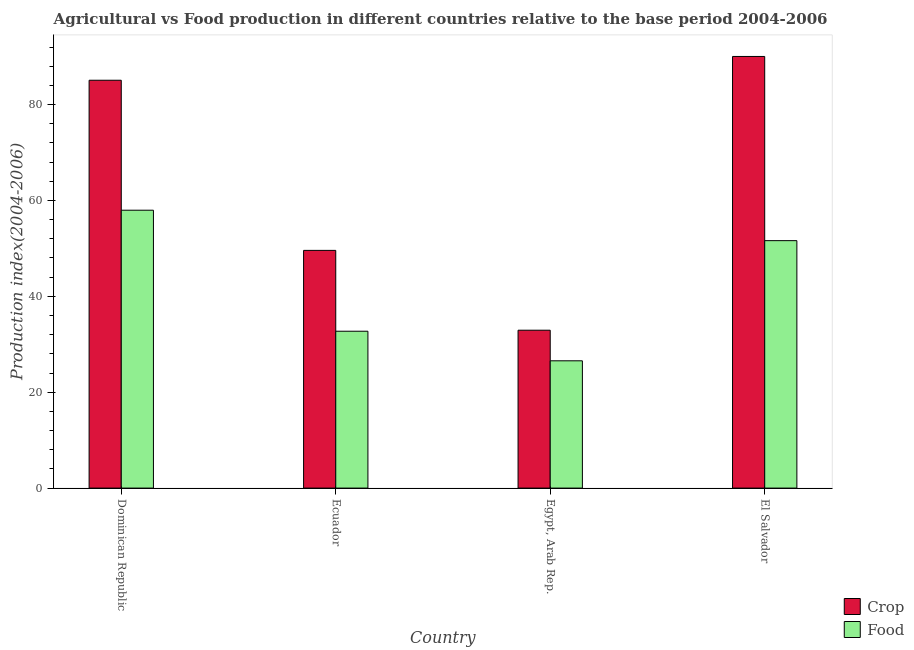Are the number of bars per tick equal to the number of legend labels?
Give a very brief answer. Yes. Are the number of bars on each tick of the X-axis equal?
Keep it short and to the point. Yes. How many bars are there on the 3rd tick from the left?
Provide a succinct answer. 2. What is the label of the 4th group of bars from the left?
Offer a terse response. El Salvador. What is the food production index in Dominican Republic?
Offer a very short reply. 57.96. Across all countries, what is the maximum food production index?
Give a very brief answer. 57.96. Across all countries, what is the minimum crop production index?
Your answer should be very brief. 32.93. In which country was the food production index maximum?
Your answer should be very brief. Dominican Republic. In which country was the crop production index minimum?
Your answer should be compact. Egypt, Arab Rep. What is the total food production index in the graph?
Your answer should be very brief. 168.84. What is the difference between the crop production index in Dominican Republic and that in Egypt, Arab Rep.?
Ensure brevity in your answer.  52.14. What is the difference between the crop production index in El Salvador and the food production index in Dominican Republic?
Provide a succinct answer. 32.07. What is the average food production index per country?
Make the answer very short. 42.21. What is the difference between the food production index and crop production index in Egypt, Arab Rep.?
Your answer should be compact. -6.38. In how many countries, is the crop production index greater than 32 ?
Give a very brief answer. 4. What is the ratio of the crop production index in Dominican Republic to that in El Salvador?
Give a very brief answer. 0.94. Is the food production index in Dominican Republic less than that in Egypt, Arab Rep.?
Provide a short and direct response. No. Is the difference between the food production index in Dominican Republic and Egypt, Arab Rep. greater than the difference between the crop production index in Dominican Republic and Egypt, Arab Rep.?
Your answer should be very brief. No. What is the difference between the highest and the second highest crop production index?
Keep it short and to the point. 4.96. What is the difference between the highest and the lowest food production index?
Your response must be concise. 31.41. In how many countries, is the crop production index greater than the average crop production index taken over all countries?
Ensure brevity in your answer.  2. What does the 2nd bar from the left in Ecuador represents?
Make the answer very short. Food. What does the 1st bar from the right in Egypt, Arab Rep. represents?
Your response must be concise. Food. How many bars are there?
Your response must be concise. 8. How many countries are there in the graph?
Offer a terse response. 4. What is the difference between two consecutive major ticks on the Y-axis?
Your response must be concise. 20. Where does the legend appear in the graph?
Your response must be concise. Bottom right. What is the title of the graph?
Provide a short and direct response. Agricultural vs Food production in different countries relative to the base period 2004-2006. Does "Under-5(female)" appear as one of the legend labels in the graph?
Offer a very short reply. No. What is the label or title of the X-axis?
Offer a very short reply. Country. What is the label or title of the Y-axis?
Keep it short and to the point. Production index(2004-2006). What is the Production index(2004-2006) of Crop in Dominican Republic?
Keep it short and to the point. 85.07. What is the Production index(2004-2006) in Food in Dominican Republic?
Keep it short and to the point. 57.96. What is the Production index(2004-2006) of Crop in Ecuador?
Offer a terse response. 49.58. What is the Production index(2004-2006) in Food in Ecuador?
Keep it short and to the point. 32.72. What is the Production index(2004-2006) in Crop in Egypt, Arab Rep.?
Make the answer very short. 32.93. What is the Production index(2004-2006) in Food in Egypt, Arab Rep.?
Provide a succinct answer. 26.55. What is the Production index(2004-2006) in Crop in El Salvador?
Your response must be concise. 90.03. What is the Production index(2004-2006) in Food in El Salvador?
Offer a terse response. 51.61. Across all countries, what is the maximum Production index(2004-2006) of Crop?
Your answer should be compact. 90.03. Across all countries, what is the maximum Production index(2004-2006) of Food?
Provide a short and direct response. 57.96. Across all countries, what is the minimum Production index(2004-2006) in Crop?
Keep it short and to the point. 32.93. Across all countries, what is the minimum Production index(2004-2006) of Food?
Provide a succinct answer. 26.55. What is the total Production index(2004-2006) of Crop in the graph?
Your answer should be compact. 257.61. What is the total Production index(2004-2006) of Food in the graph?
Give a very brief answer. 168.84. What is the difference between the Production index(2004-2006) of Crop in Dominican Republic and that in Ecuador?
Offer a terse response. 35.49. What is the difference between the Production index(2004-2006) of Food in Dominican Republic and that in Ecuador?
Provide a short and direct response. 25.24. What is the difference between the Production index(2004-2006) of Crop in Dominican Republic and that in Egypt, Arab Rep.?
Your answer should be very brief. 52.14. What is the difference between the Production index(2004-2006) of Food in Dominican Republic and that in Egypt, Arab Rep.?
Your answer should be very brief. 31.41. What is the difference between the Production index(2004-2006) of Crop in Dominican Republic and that in El Salvador?
Offer a terse response. -4.96. What is the difference between the Production index(2004-2006) of Food in Dominican Republic and that in El Salvador?
Give a very brief answer. 6.35. What is the difference between the Production index(2004-2006) in Crop in Ecuador and that in Egypt, Arab Rep.?
Make the answer very short. 16.65. What is the difference between the Production index(2004-2006) in Food in Ecuador and that in Egypt, Arab Rep.?
Offer a terse response. 6.17. What is the difference between the Production index(2004-2006) in Crop in Ecuador and that in El Salvador?
Your response must be concise. -40.45. What is the difference between the Production index(2004-2006) of Food in Ecuador and that in El Salvador?
Ensure brevity in your answer.  -18.89. What is the difference between the Production index(2004-2006) in Crop in Egypt, Arab Rep. and that in El Salvador?
Keep it short and to the point. -57.1. What is the difference between the Production index(2004-2006) in Food in Egypt, Arab Rep. and that in El Salvador?
Your answer should be compact. -25.06. What is the difference between the Production index(2004-2006) of Crop in Dominican Republic and the Production index(2004-2006) of Food in Ecuador?
Provide a short and direct response. 52.35. What is the difference between the Production index(2004-2006) in Crop in Dominican Republic and the Production index(2004-2006) in Food in Egypt, Arab Rep.?
Provide a short and direct response. 58.52. What is the difference between the Production index(2004-2006) of Crop in Dominican Republic and the Production index(2004-2006) of Food in El Salvador?
Offer a terse response. 33.46. What is the difference between the Production index(2004-2006) in Crop in Ecuador and the Production index(2004-2006) in Food in Egypt, Arab Rep.?
Your answer should be very brief. 23.03. What is the difference between the Production index(2004-2006) of Crop in Ecuador and the Production index(2004-2006) of Food in El Salvador?
Ensure brevity in your answer.  -2.03. What is the difference between the Production index(2004-2006) of Crop in Egypt, Arab Rep. and the Production index(2004-2006) of Food in El Salvador?
Provide a short and direct response. -18.68. What is the average Production index(2004-2006) in Crop per country?
Offer a terse response. 64.4. What is the average Production index(2004-2006) of Food per country?
Your response must be concise. 42.21. What is the difference between the Production index(2004-2006) in Crop and Production index(2004-2006) in Food in Dominican Republic?
Provide a succinct answer. 27.11. What is the difference between the Production index(2004-2006) of Crop and Production index(2004-2006) of Food in Ecuador?
Keep it short and to the point. 16.86. What is the difference between the Production index(2004-2006) in Crop and Production index(2004-2006) in Food in Egypt, Arab Rep.?
Offer a very short reply. 6.38. What is the difference between the Production index(2004-2006) of Crop and Production index(2004-2006) of Food in El Salvador?
Provide a succinct answer. 38.42. What is the ratio of the Production index(2004-2006) in Crop in Dominican Republic to that in Ecuador?
Give a very brief answer. 1.72. What is the ratio of the Production index(2004-2006) in Food in Dominican Republic to that in Ecuador?
Provide a succinct answer. 1.77. What is the ratio of the Production index(2004-2006) in Crop in Dominican Republic to that in Egypt, Arab Rep.?
Ensure brevity in your answer.  2.58. What is the ratio of the Production index(2004-2006) of Food in Dominican Republic to that in Egypt, Arab Rep.?
Provide a succinct answer. 2.18. What is the ratio of the Production index(2004-2006) in Crop in Dominican Republic to that in El Salvador?
Your response must be concise. 0.94. What is the ratio of the Production index(2004-2006) in Food in Dominican Republic to that in El Salvador?
Provide a succinct answer. 1.12. What is the ratio of the Production index(2004-2006) of Crop in Ecuador to that in Egypt, Arab Rep.?
Provide a succinct answer. 1.51. What is the ratio of the Production index(2004-2006) in Food in Ecuador to that in Egypt, Arab Rep.?
Your response must be concise. 1.23. What is the ratio of the Production index(2004-2006) in Crop in Ecuador to that in El Salvador?
Ensure brevity in your answer.  0.55. What is the ratio of the Production index(2004-2006) of Food in Ecuador to that in El Salvador?
Your answer should be very brief. 0.63. What is the ratio of the Production index(2004-2006) in Crop in Egypt, Arab Rep. to that in El Salvador?
Your response must be concise. 0.37. What is the ratio of the Production index(2004-2006) of Food in Egypt, Arab Rep. to that in El Salvador?
Provide a succinct answer. 0.51. What is the difference between the highest and the second highest Production index(2004-2006) in Crop?
Your response must be concise. 4.96. What is the difference between the highest and the second highest Production index(2004-2006) in Food?
Provide a short and direct response. 6.35. What is the difference between the highest and the lowest Production index(2004-2006) in Crop?
Your response must be concise. 57.1. What is the difference between the highest and the lowest Production index(2004-2006) in Food?
Offer a very short reply. 31.41. 